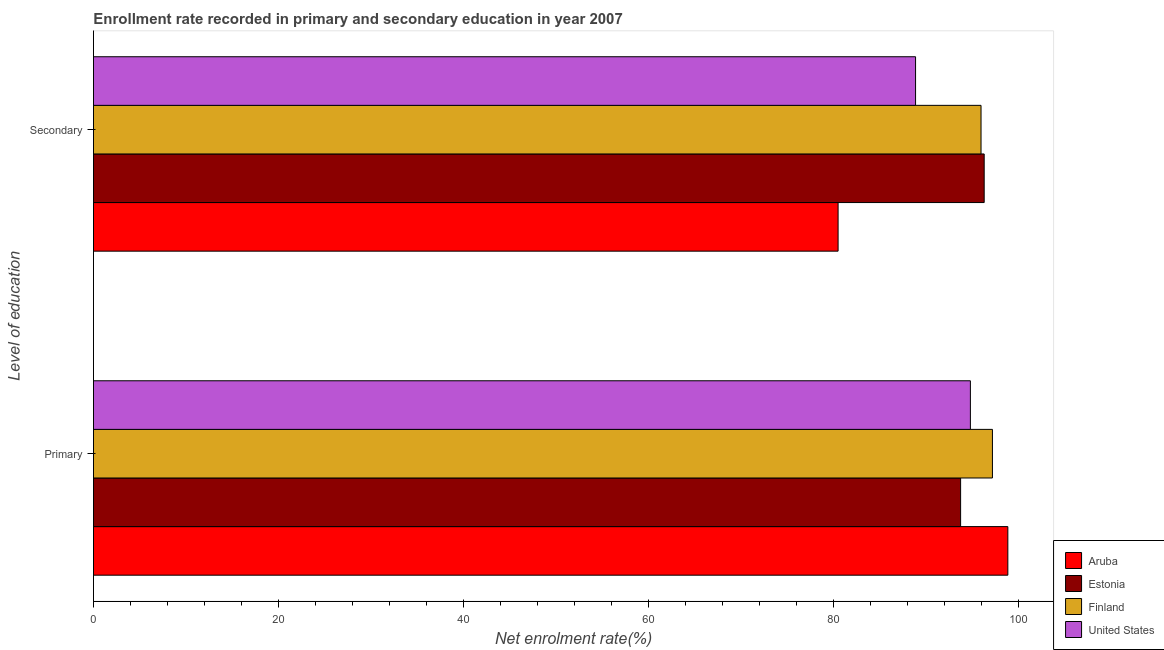How many different coloured bars are there?
Provide a succinct answer. 4. Are the number of bars per tick equal to the number of legend labels?
Your answer should be very brief. Yes. How many bars are there on the 2nd tick from the bottom?
Offer a terse response. 4. What is the label of the 2nd group of bars from the top?
Your answer should be compact. Primary. What is the enrollment rate in primary education in Estonia?
Offer a terse response. 93.77. Across all countries, what is the maximum enrollment rate in primary education?
Give a very brief answer. 98.87. Across all countries, what is the minimum enrollment rate in secondary education?
Offer a terse response. 80.52. In which country was the enrollment rate in secondary education maximum?
Ensure brevity in your answer.  Estonia. In which country was the enrollment rate in secondary education minimum?
Your response must be concise. Aruba. What is the total enrollment rate in primary education in the graph?
Keep it short and to the point. 384.67. What is the difference between the enrollment rate in primary education in United States and that in Aruba?
Give a very brief answer. -4.05. What is the difference between the enrollment rate in secondary education in Estonia and the enrollment rate in primary education in Aruba?
Your response must be concise. -2.56. What is the average enrollment rate in primary education per country?
Your answer should be compact. 96.17. What is the difference between the enrollment rate in primary education and enrollment rate in secondary education in Finland?
Your response must be concise. 1.23. In how many countries, is the enrollment rate in secondary education greater than 68 %?
Your answer should be very brief. 4. What is the ratio of the enrollment rate in primary education in United States to that in Aruba?
Make the answer very short. 0.96. Is the enrollment rate in secondary education in Aruba less than that in United States?
Provide a succinct answer. Yes. In how many countries, is the enrollment rate in secondary education greater than the average enrollment rate in secondary education taken over all countries?
Give a very brief answer. 2. What does the 1st bar from the top in Secondary represents?
Offer a terse response. United States. What does the 1st bar from the bottom in Secondary represents?
Your response must be concise. Aruba. Are all the bars in the graph horizontal?
Give a very brief answer. Yes. How many countries are there in the graph?
Make the answer very short. 4. Are the values on the major ticks of X-axis written in scientific E-notation?
Provide a short and direct response. No. Does the graph contain any zero values?
Offer a very short reply. No. Does the graph contain grids?
Ensure brevity in your answer.  No. What is the title of the graph?
Provide a short and direct response. Enrollment rate recorded in primary and secondary education in year 2007. Does "Tajikistan" appear as one of the legend labels in the graph?
Offer a terse response. No. What is the label or title of the X-axis?
Your answer should be very brief. Net enrolment rate(%). What is the label or title of the Y-axis?
Provide a succinct answer. Level of education. What is the Net enrolment rate(%) of Aruba in Primary?
Provide a succinct answer. 98.87. What is the Net enrolment rate(%) of Estonia in Primary?
Your response must be concise. 93.77. What is the Net enrolment rate(%) in Finland in Primary?
Provide a succinct answer. 97.21. What is the Net enrolment rate(%) in United States in Primary?
Make the answer very short. 94.82. What is the Net enrolment rate(%) in Aruba in Secondary?
Offer a terse response. 80.52. What is the Net enrolment rate(%) of Estonia in Secondary?
Give a very brief answer. 96.32. What is the Net enrolment rate(%) in Finland in Secondary?
Make the answer very short. 95.97. What is the Net enrolment rate(%) in United States in Secondary?
Keep it short and to the point. 88.89. Across all Level of education, what is the maximum Net enrolment rate(%) of Aruba?
Provide a short and direct response. 98.87. Across all Level of education, what is the maximum Net enrolment rate(%) in Estonia?
Provide a succinct answer. 96.32. Across all Level of education, what is the maximum Net enrolment rate(%) of Finland?
Your answer should be very brief. 97.21. Across all Level of education, what is the maximum Net enrolment rate(%) of United States?
Ensure brevity in your answer.  94.82. Across all Level of education, what is the minimum Net enrolment rate(%) in Aruba?
Your answer should be very brief. 80.52. Across all Level of education, what is the minimum Net enrolment rate(%) in Estonia?
Keep it short and to the point. 93.77. Across all Level of education, what is the minimum Net enrolment rate(%) of Finland?
Offer a very short reply. 95.97. Across all Level of education, what is the minimum Net enrolment rate(%) of United States?
Keep it short and to the point. 88.89. What is the total Net enrolment rate(%) of Aruba in the graph?
Your response must be concise. 179.39. What is the total Net enrolment rate(%) of Estonia in the graph?
Provide a succinct answer. 190.08. What is the total Net enrolment rate(%) of Finland in the graph?
Give a very brief answer. 193.18. What is the total Net enrolment rate(%) of United States in the graph?
Your answer should be compact. 183.72. What is the difference between the Net enrolment rate(%) in Aruba in Primary and that in Secondary?
Make the answer very short. 18.36. What is the difference between the Net enrolment rate(%) in Estonia in Primary and that in Secondary?
Provide a succinct answer. -2.55. What is the difference between the Net enrolment rate(%) of Finland in Primary and that in Secondary?
Make the answer very short. 1.23. What is the difference between the Net enrolment rate(%) in United States in Primary and that in Secondary?
Keep it short and to the point. 5.93. What is the difference between the Net enrolment rate(%) in Aruba in Primary and the Net enrolment rate(%) in Estonia in Secondary?
Give a very brief answer. 2.56. What is the difference between the Net enrolment rate(%) of Aruba in Primary and the Net enrolment rate(%) of Finland in Secondary?
Keep it short and to the point. 2.9. What is the difference between the Net enrolment rate(%) of Aruba in Primary and the Net enrolment rate(%) of United States in Secondary?
Make the answer very short. 9.98. What is the difference between the Net enrolment rate(%) of Estonia in Primary and the Net enrolment rate(%) of Finland in Secondary?
Give a very brief answer. -2.21. What is the difference between the Net enrolment rate(%) of Estonia in Primary and the Net enrolment rate(%) of United States in Secondary?
Your answer should be very brief. 4.87. What is the difference between the Net enrolment rate(%) of Finland in Primary and the Net enrolment rate(%) of United States in Secondary?
Provide a succinct answer. 8.31. What is the average Net enrolment rate(%) in Aruba per Level of education?
Your answer should be compact. 89.69. What is the average Net enrolment rate(%) of Estonia per Level of education?
Provide a succinct answer. 95.04. What is the average Net enrolment rate(%) of Finland per Level of education?
Provide a short and direct response. 96.59. What is the average Net enrolment rate(%) of United States per Level of education?
Give a very brief answer. 91.86. What is the difference between the Net enrolment rate(%) in Aruba and Net enrolment rate(%) in Estonia in Primary?
Your answer should be very brief. 5.11. What is the difference between the Net enrolment rate(%) of Aruba and Net enrolment rate(%) of Finland in Primary?
Keep it short and to the point. 1.67. What is the difference between the Net enrolment rate(%) of Aruba and Net enrolment rate(%) of United States in Primary?
Give a very brief answer. 4.05. What is the difference between the Net enrolment rate(%) in Estonia and Net enrolment rate(%) in Finland in Primary?
Your response must be concise. -3.44. What is the difference between the Net enrolment rate(%) in Estonia and Net enrolment rate(%) in United States in Primary?
Your answer should be very brief. -1.06. What is the difference between the Net enrolment rate(%) in Finland and Net enrolment rate(%) in United States in Primary?
Offer a terse response. 2.38. What is the difference between the Net enrolment rate(%) of Aruba and Net enrolment rate(%) of Estonia in Secondary?
Keep it short and to the point. -15.8. What is the difference between the Net enrolment rate(%) in Aruba and Net enrolment rate(%) in Finland in Secondary?
Provide a succinct answer. -15.46. What is the difference between the Net enrolment rate(%) in Aruba and Net enrolment rate(%) in United States in Secondary?
Your response must be concise. -8.38. What is the difference between the Net enrolment rate(%) of Estonia and Net enrolment rate(%) of Finland in Secondary?
Make the answer very short. 0.34. What is the difference between the Net enrolment rate(%) of Estonia and Net enrolment rate(%) of United States in Secondary?
Keep it short and to the point. 7.42. What is the difference between the Net enrolment rate(%) in Finland and Net enrolment rate(%) in United States in Secondary?
Give a very brief answer. 7.08. What is the ratio of the Net enrolment rate(%) of Aruba in Primary to that in Secondary?
Give a very brief answer. 1.23. What is the ratio of the Net enrolment rate(%) of Estonia in Primary to that in Secondary?
Your answer should be very brief. 0.97. What is the ratio of the Net enrolment rate(%) in Finland in Primary to that in Secondary?
Offer a very short reply. 1.01. What is the ratio of the Net enrolment rate(%) of United States in Primary to that in Secondary?
Offer a very short reply. 1.07. What is the difference between the highest and the second highest Net enrolment rate(%) in Aruba?
Provide a short and direct response. 18.36. What is the difference between the highest and the second highest Net enrolment rate(%) in Estonia?
Make the answer very short. 2.55. What is the difference between the highest and the second highest Net enrolment rate(%) of Finland?
Make the answer very short. 1.23. What is the difference between the highest and the second highest Net enrolment rate(%) of United States?
Offer a terse response. 5.93. What is the difference between the highest and the lowest Net enrolment rate(%) of Aruba?
Make the answer very short. 18.36. What is the difference between the highest and the lowest Net enrolment rate(%) in Estonia?
Provide a short and direct response. 2.55. What is the difference between the highest and the lowest Net enrolment rate(%) of Finland?
Make the answer very short. 1.23. What is the difference between the highest and the lowest Net enrolment rate(%) in United States?
Provide a short and direct response. 5.93. 